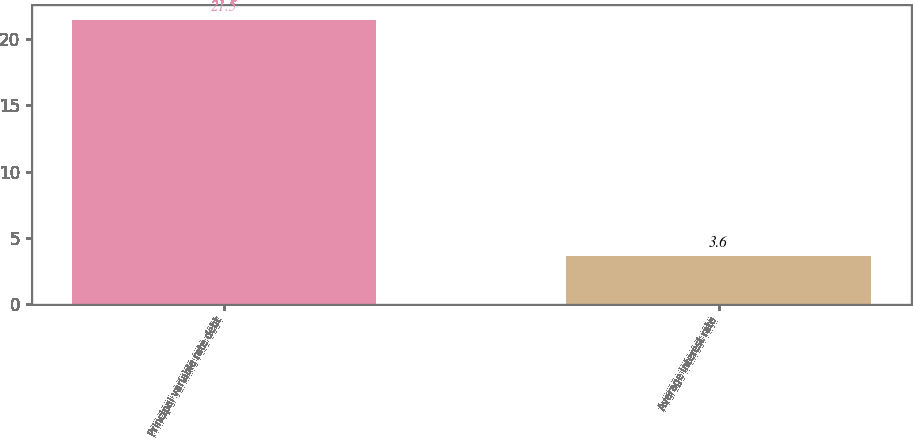Convert chart. <chart><loc_0><loc_0><loc_500><loc_500><bar_chart><fcel>Principal variable rate debt<fcel>Average interest rate<nl><fcel>21.5<fcel>3.6<nl></chart> 